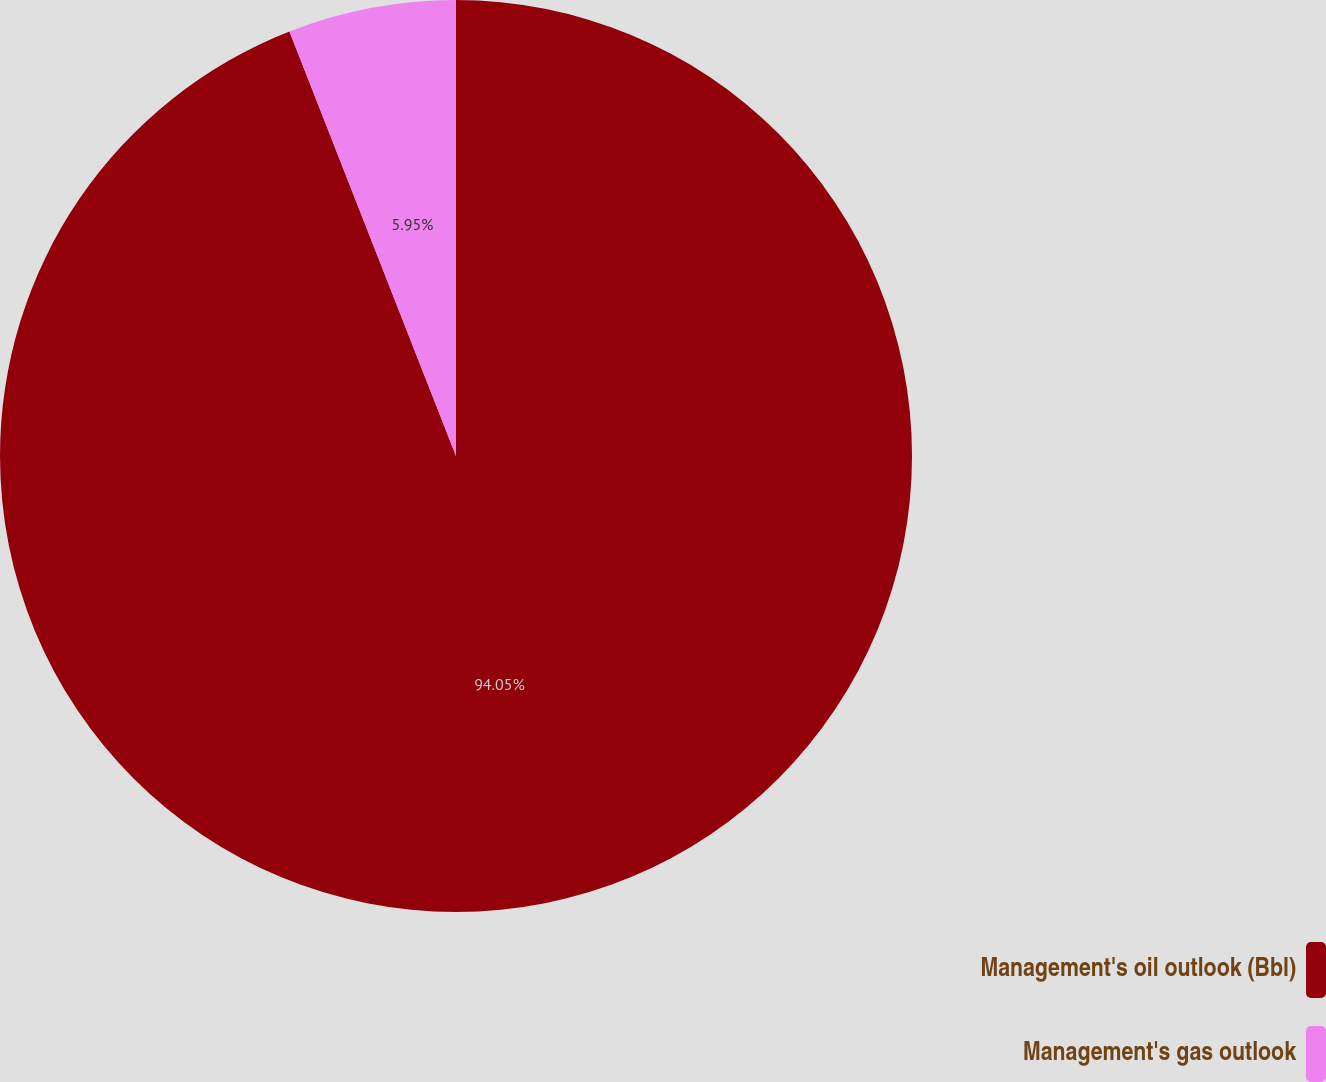Convert chart. <chart><loc_0><loc_0><loc_500><loc_500><pie_chart><fcel>Management's oil outlook (Bbl)<fcel>Management's gas outlook<nl><fcel>94.05%<fcel>5.95%<nl></chart> 